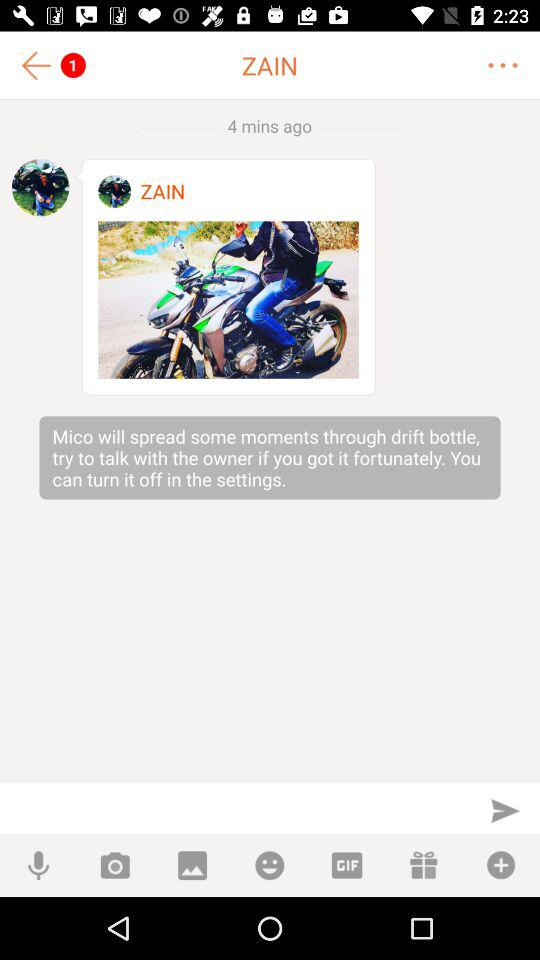What is the user name? The user name is Zain. 